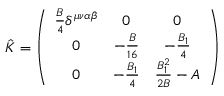<formula> <loc_0><loc_0><loc_500><loc_500>\hat { K } = \left ( \begin{array} { c c c } { { \frac { B } { 4 } \delta ^ { \mu \nu \alpha \beta } } } & { 0 } & { 0 } \\ { 0 } & { { - \frac { B } { 1 6 } } } & { { - \frac { B _ { 1 } } { 4 } } } \\ { 0 } & { { - \frac { B _ { 1 } } { 4 } } } & { { \frac { B _ { 1 } ^ { 2 } } { 2 B } - A } } \end{array} \right )</formula> 